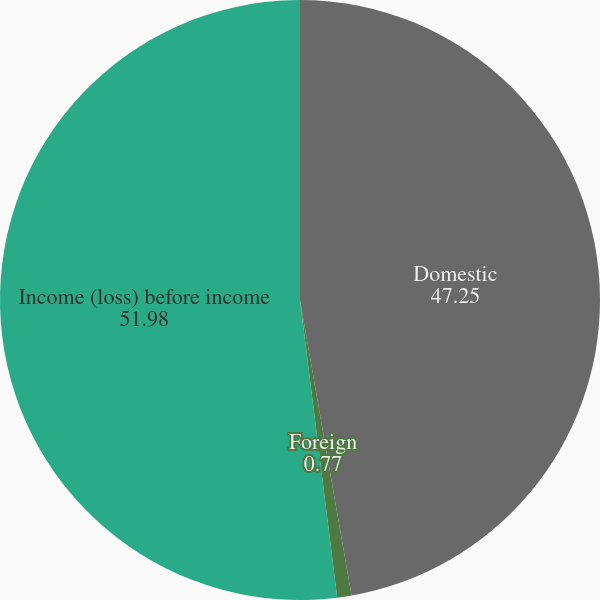Convert chart to OTSL. <chart><loc_0><loc_0><loc_500><loc_500><pie_chart><fcel>Domestic<fcel>Foreign<fcel>Income (loss) before income<nl><fcel>47.25%<fcel>0.77%<fcel>51.98%<nl></chart> 